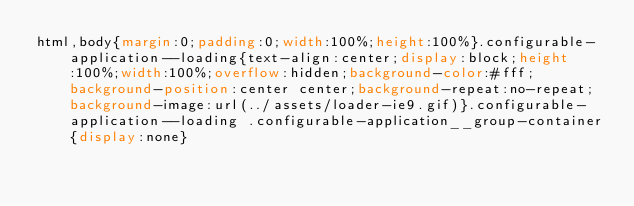<code> <loc_0><loc_0><loc_500><loc_500><_CSS_>html,body{margin:0;padding:0;width:100%;height:100%}.configurable-application--loading{text-align:center;display:block;height:100%;width:100%;overflow:hidden;background-color:#fff;background-position:center center;background-repeat:no-repeat;background-image:url(../assets/loader-ie9.gif)}.configurable-application--loading .configurable-application__group-container{display:none}
</code> 